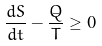Convert formula to latex. <formula><loc_0><loc_0><loc_500><loc_500>\frac { d S } { d t } - \frac { \dot { Q } } { T } \geq 0</formula> 